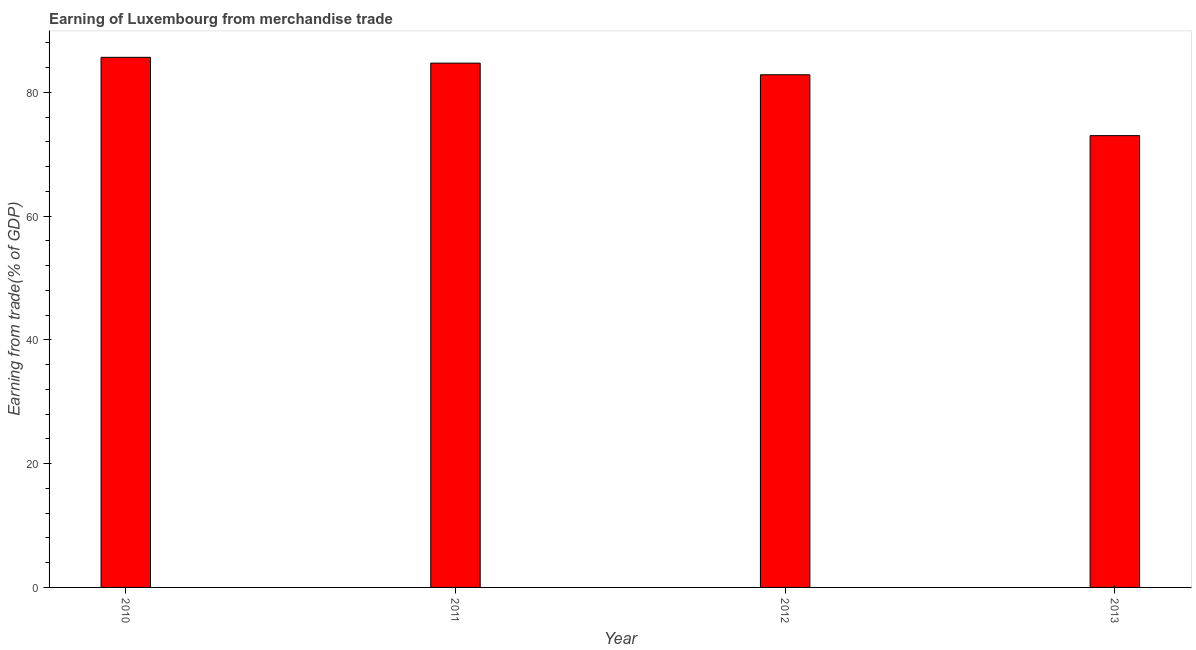What is the title of the graph?
Your answer should be very brief. Earning of Luxembourg from merchandise trade. What is the label or title of the Y-axis?
Provide a succinct answer. Earning from trade(% of GDP). What is the earning from merchandise trade in 2013?
Make the answer very short. 73. Across all years, what is the maximum earning from merchandise trade?
Provide a short and direct response. 85.65. Across all years, what is the minimum earning from merchandise trade?
Ensure brevity in your answer.  73. What is the sum of the earning from merchandise trade?
Ensure brevity in your answer.  326.2. What is the difference between the earning from merchandise trade in 2011 and 2013?
Offer a terse response. 11.71. What is the average earning from merchandise trade per year?
Give a very brief answer. 81.55. What is the median earning from merchandise trade?
Your answer should be very brief. 83.78. What is the ratio of the earning from merchandise trade in 2012 to that in 2013?
Ensure brevity in your answer.  1.14. What is the difference between the highest and the second highest earning from merchandise trade?
Keep it short and to the point. 0.94. Is the sum of the earning from merchandise trade in 2010 and 2013 greater than the maximum earning from merchandise trade across all years?
Make the answer very short. Yes. What is the difference between the highest and the lowest earning from merchandise trade?
Your response must be concise. 12.65. Are all the bars in the graph horizontal?
Keep it short and to the point. No. What is the difference between two consecutive major ticks on the Y-axis?
Keep it short and to the point. 20. Are the values on the major ticks of Y-axis written in scientific E-notation?
Offer a very short reply. No. What is the Earning from trade(% of GDP) of 2010?
Your answer should be compact. 85.65. What is the Earning from trade(% of GDP) in 2011?
Your answer should be very brief. 84.72. What is the Earning from trade(% of GDP) of 2012?
Make the answer very short. 82.83. What is the Earning from trade(% of GDP) in 2013?
Give a very brief answer. 73. What is the difference between the Earning from trade(% of GDP) in 2010 and 2011?
Make the answer very short. 0.94. What is the difference between the Earning from trade(% of GDP) in 2010 and 2012?
Offer a terse response. 2.82. What is the difference between the Earning from trade(% of GDP) in 2010 and 2013?
Ensure brevity in your answer.  12.65. What is the difference between the Earning from trade(% of GDP) in 2011 and 2012?
Provide a succinct answer. 1.88. What is the difference between the Earning from trade(% of GDP) in 2011 and 2013?
Your answer should be compact. 11.71. What is the difference between the Earning from trade(% of GDP) in 2012 and 2013?
Make the answer very short. 9.83. What is the ratio of the Earning from trade(% of GDP) in 2010 to that in 2012?
Offer a very short reply. 1.03. What is the ratio of the Earning from trade(% of GDP) in 2010 to that in 2013?
Your answer should be compact. 1.17. What is the ratio of the Earning from trade(% of GDP) in 2011 to that in 2012?
Give a very brief answer. 1.02. What is the ratio of the Earning from trade(% of GDP) in 2011 to that in 2013?
Your response must be concise. 1.16. What is the ratio of the Earning from trade(% of GDP) in 2012 to that in 2013?
Provide a short and direct response. 1.14. 